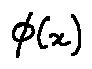Convert formula to latex. <formula><loc_0><loc_0><loc_500><loc_500>\phi ( x )</formula> 